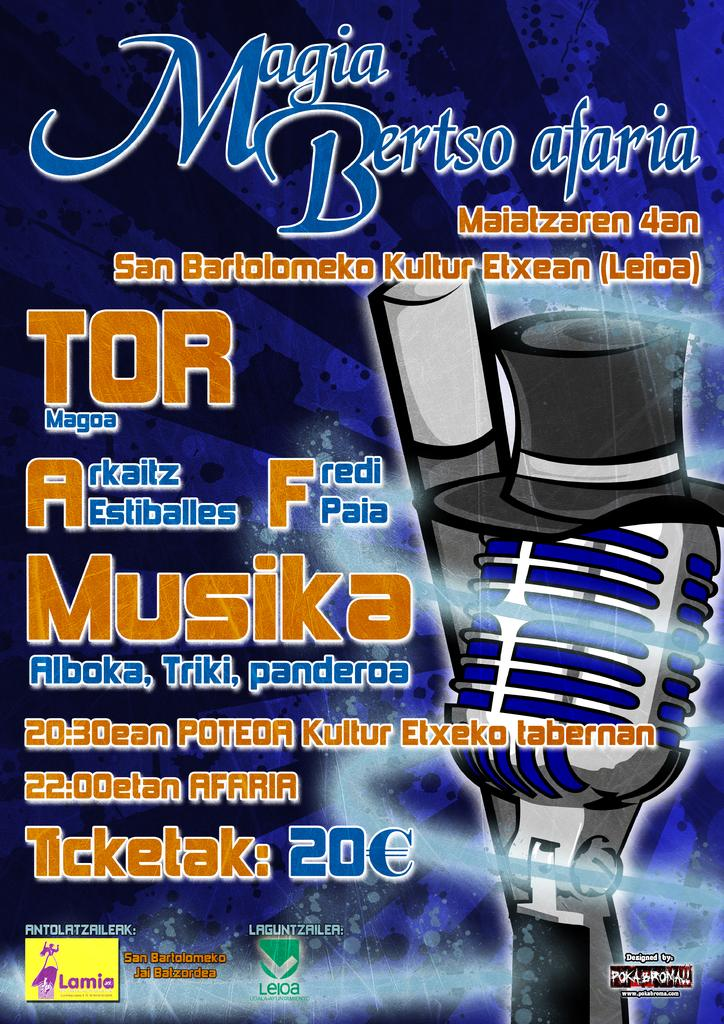<image>
Offer a succinct explanation of the picture presented. A poster advertising Magia Bertso afaria was designed by Pokabroma. 